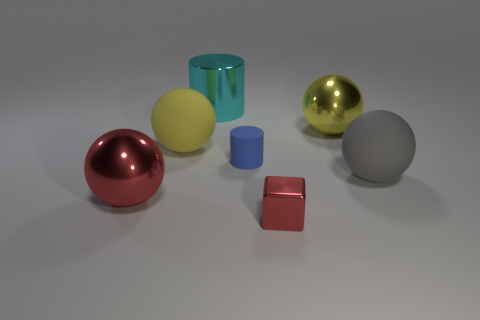Add 1 small green cylinders. How many objects exist? 8 Subtract all gray spheres. How many spheres are left? 3 Subtract all cylinders. How many objects are left? 5 Subtract 4 spheres. How many spheres are left? 0 Subtract all green blocks. Subtract all green cylinders. How many blocks are left? 1 Subtract all gray blocks. How many gray balls are left? 1 Subtract all small green cubes. Subtract all large cylinders. How many objects are left? 6 Add 6 large yellow things. How many large yellow things are left? 8 Add 4 matte cylinders. How many matte cylinders exist? 5 Subtract 0 blue cubes. How many objects are left? 7 